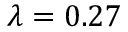Convert formula to latex. <formula><loc_0><loc_0><loc_500><loc_500>\lambda = 0 . 2 7</formula> 